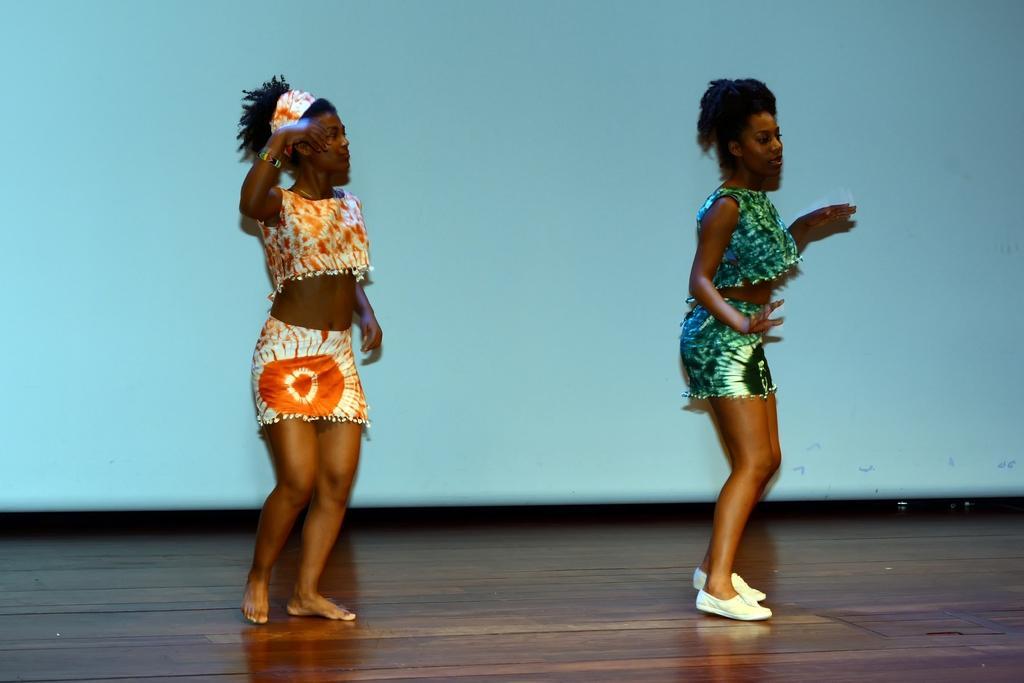Can you describe this image briefly? In this picture I can see there are two women standing, there is a dais and there is a blue surface in the backdrop. 